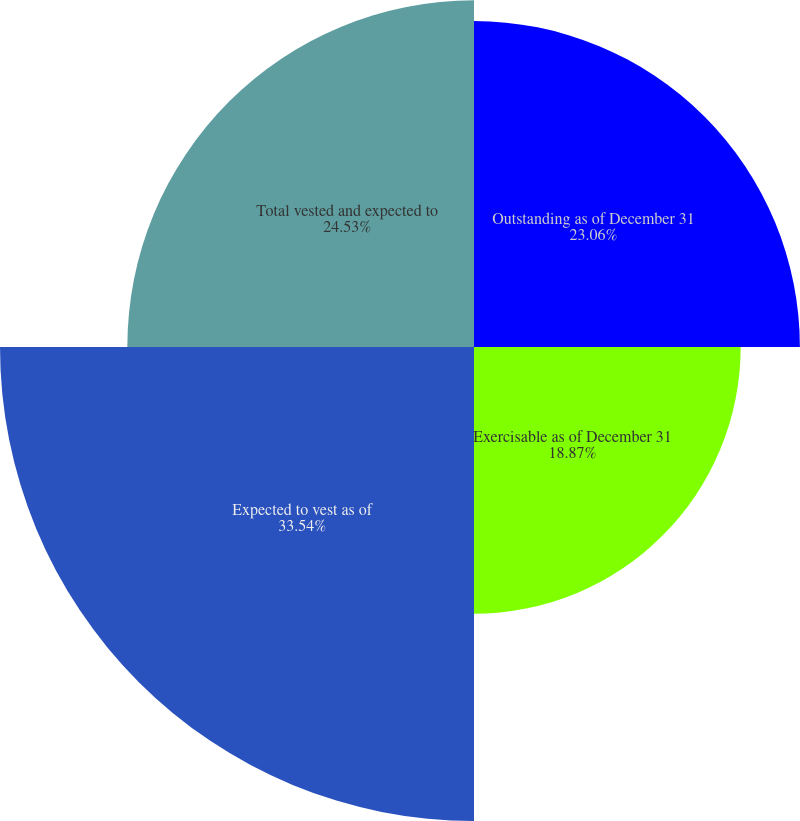<chart> <loc_0><loc_0><loc_500><loc_500><pie_chart><fcel>Outstanding as of December 31<fcel>Exercisable as of December 31<fcel>Expected to vest as of<fcel>Total vested and expected to<nl><fcel>23.06%<fcel>18.87%<fcel>33.54%<fcel>24.53%<nl></chart> 